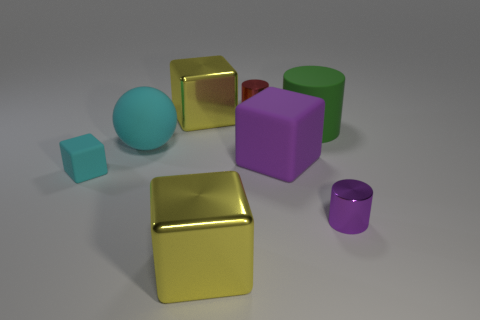What number of things are either blocks in front of the big cyan matte ball or small red matte blocks?
Offer a very short reply. 3. How many big matte things are to the left of the block that is right of the tiny red shiny thing?
Make the answer very short. 1. What size is the cyan matte object that is behind the matte block that is on the right side of the large shiny block that is behind the tiny matte cube?
Make the answer very short. Large. There is a thing on the left side of the rubber ball; is it the same color as the large rubber sphere?
Provide a short and direct response. Yes. What size is the other purple object that is the same shape as the small rubber object?
Your response must be concise. Large. How many objects are either big shiny objects in front of the purple rubber cube or matte things on the left side of the red metallic cylinder?
Give a very brief answer. 3. There is a yellow shiny thing that is in front of the tiny cylinder in front of the big purple rubber cube; what shape is it?
Offer a very short reply. Cube. Is there anything else that is the same color as the small matte thing?
Keep it short and to the point. Yes. How many objects are red things or things?
Your answer should be very brief. 8. Are there any cyan rubber things of the same size as the green rubber object?
Provide a short and direct response. Yes. 